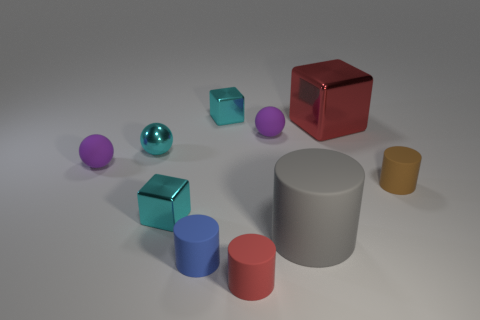Subtract all small cubes. How many cubes are left? 1 Subtract all cubes. How many objects are left? 7 Subtract all red blocks. How many blocks are left? 2 Subtract 2 cylinders. How many cylinders are left? 2 Subtract all blue cylinders. How many blue balls are left? 0 Subtract all big gray spheres. Subtract all blue cylinders. How many objects are left? 9 Add 6 small cylinders. How many small cylinders are left? 9 Add 6 tiny red rubber cylinders. How many tiny red rubber cylinders exist? 7 Subtract 1 red cylinders. How many objects are left? 9 Subtract all green balls. Subtract all brown cubes. How many balls are left? 3 